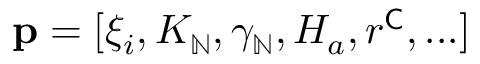<formula> <loc_0><loc_0><loc_500><loc_500>p = [ \xi _ { i } , K _ { \mathbb { N } } , \gamma _ { \mathbb { N } } , H _ { a } , r ^ { C } , \dots ]</formula> 